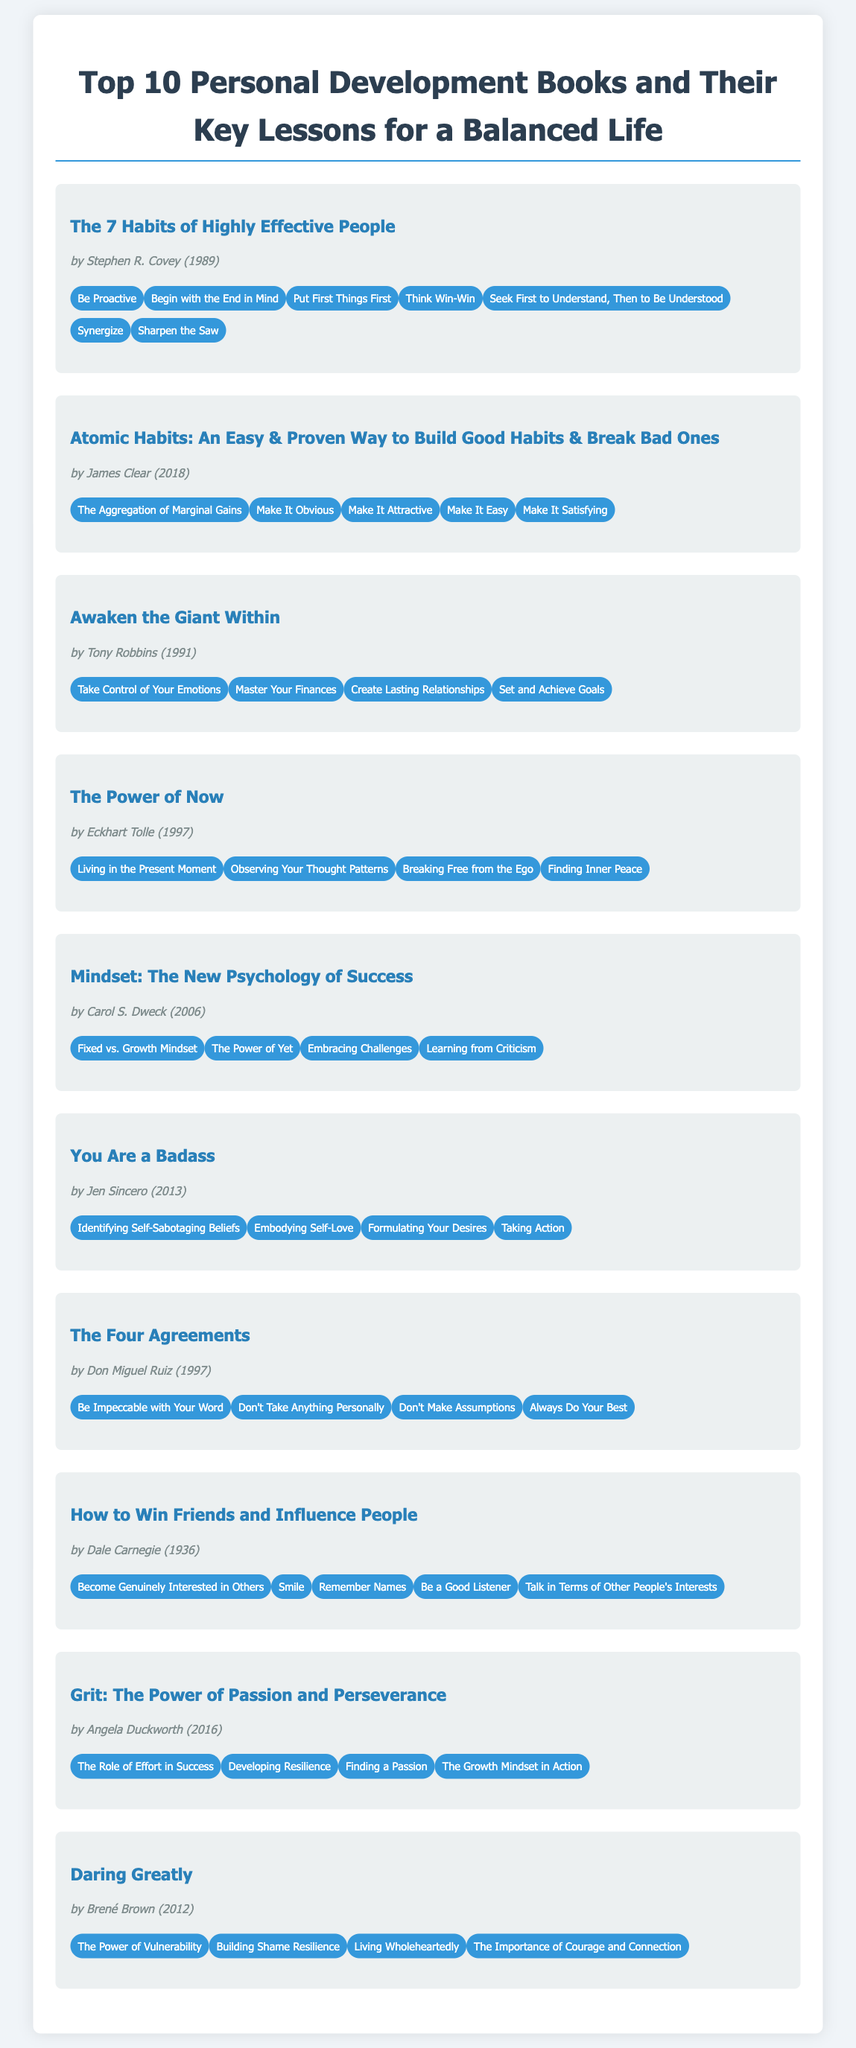What is the title of the first book? The title of the first book is found at the top of the bibliography section.
Answer: The 7 Habits of Highly Effective People Who is the author of "Atomic Habits"? The author of "Atomic Habits" is listed under the book information in the document.
Answer: James Clear In what year was "You Are a Badass" published? The publication year is provided alongside each book's title and author.
Answer: 2013 How many key lessons does "Daring Greatly" have? The number of lessons can be counted from the list under "Daring Greatly".
Answer: 4 Which book discusses the concept of "Growth Mindset"? This concept is featured among the key lessons of a specific book and can be identified by reviewing the lessons.
Answer: Mindset: The New Psychology of Success Who wrote "The Four Agreements"? The author’s name is associated with the book title in the bibliography.
Answer: Don Miguel Ruiz What is one key lesson from "The Power of Now"? This information can be retrieved by looking under the corresponding book.
Answer: Living in the Present Moment What is the common theme of the books in this bibliography? The overall theme can be inferred from the titles and lessons of the listed books.
Answer: Personal development How many books were published before the year 2000? This requires counting the publication years listed next to each book.
Answer: 5 